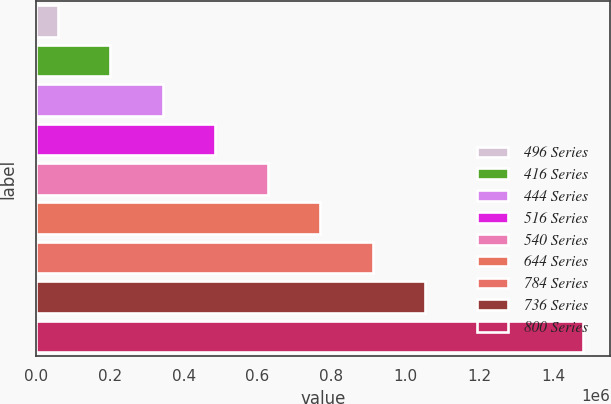<chart> <loc_0><loc_0><loc_500><loc_500><bar_chart><fcel>496 Series<fcel>416 Series<fcel>444 Series<fcel>516 Series<fcel>540 Series<fcel>644 Series<fcel>784 Series<fcel>736 Series<fcel>800 Series<nl><fcel>60000<fcel>202000<fcel>344000<fcel>486000<fcel>628000<fcel>770000<fcel>912000<fcel>1.054e+06<fcel>1.48e+06<nl></chart> 